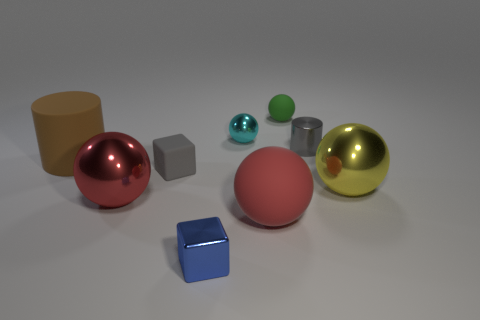Subtract all large balls. How many balls are left? 2 Subtract all red spheres. How many brown cylinders are left? 1 Subtract all green spheres. How many spheres are left? 4 Subtract all cylinders. How many objects are left? 7 Subtract all brown cylinders. Subtract all cyan blocks. How many cylinders are left? 1 Subtract all small blue shiny spheres. Subtract all rubber spheres. How many objects are left? 7 Add 1 gray metal cylinders. How many gray metal cylinders are left? 2 Add 4 small spheres. How many small spheres exist? 6 Add 1 small gray cylinders. How many objects exist? 10 Subtract 0 cyan cylinders. How many objects are left? 9 